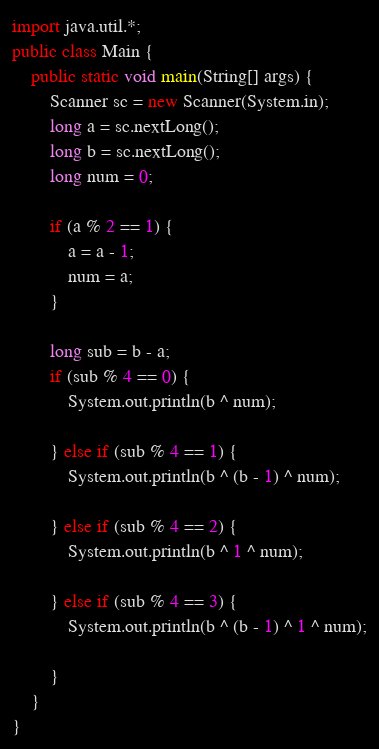<code> <loc_0><loc_0><loc_500><loc_500><_Java_>import java.util.*;
public class Main {
    public static void main(String[] args) {
        Scanner sc = new Scanner(System.in);
        long a = sc.nextLong();
        long b = sc.nextLong();
        long num = 0;

        if (a % 2 == 1) {
            a = a - 1;
            num = a;
        }

        long sub = b - a;
        if (sub % 4 == 0) {
            System.out.println(b ^ num);

        } else if (sub % 4 == 1) {
            System.out.println(b ^ (b - 1) ^ num);

        } else if (sub % 4 == 2) {
            System.out.println(b ^ 1 ^ num);

        } else if (sub % 4 == 3) {
            System.out.println(b ^ (b - 1) ^ 1 ^ num);

        }
    }
}

</code> 